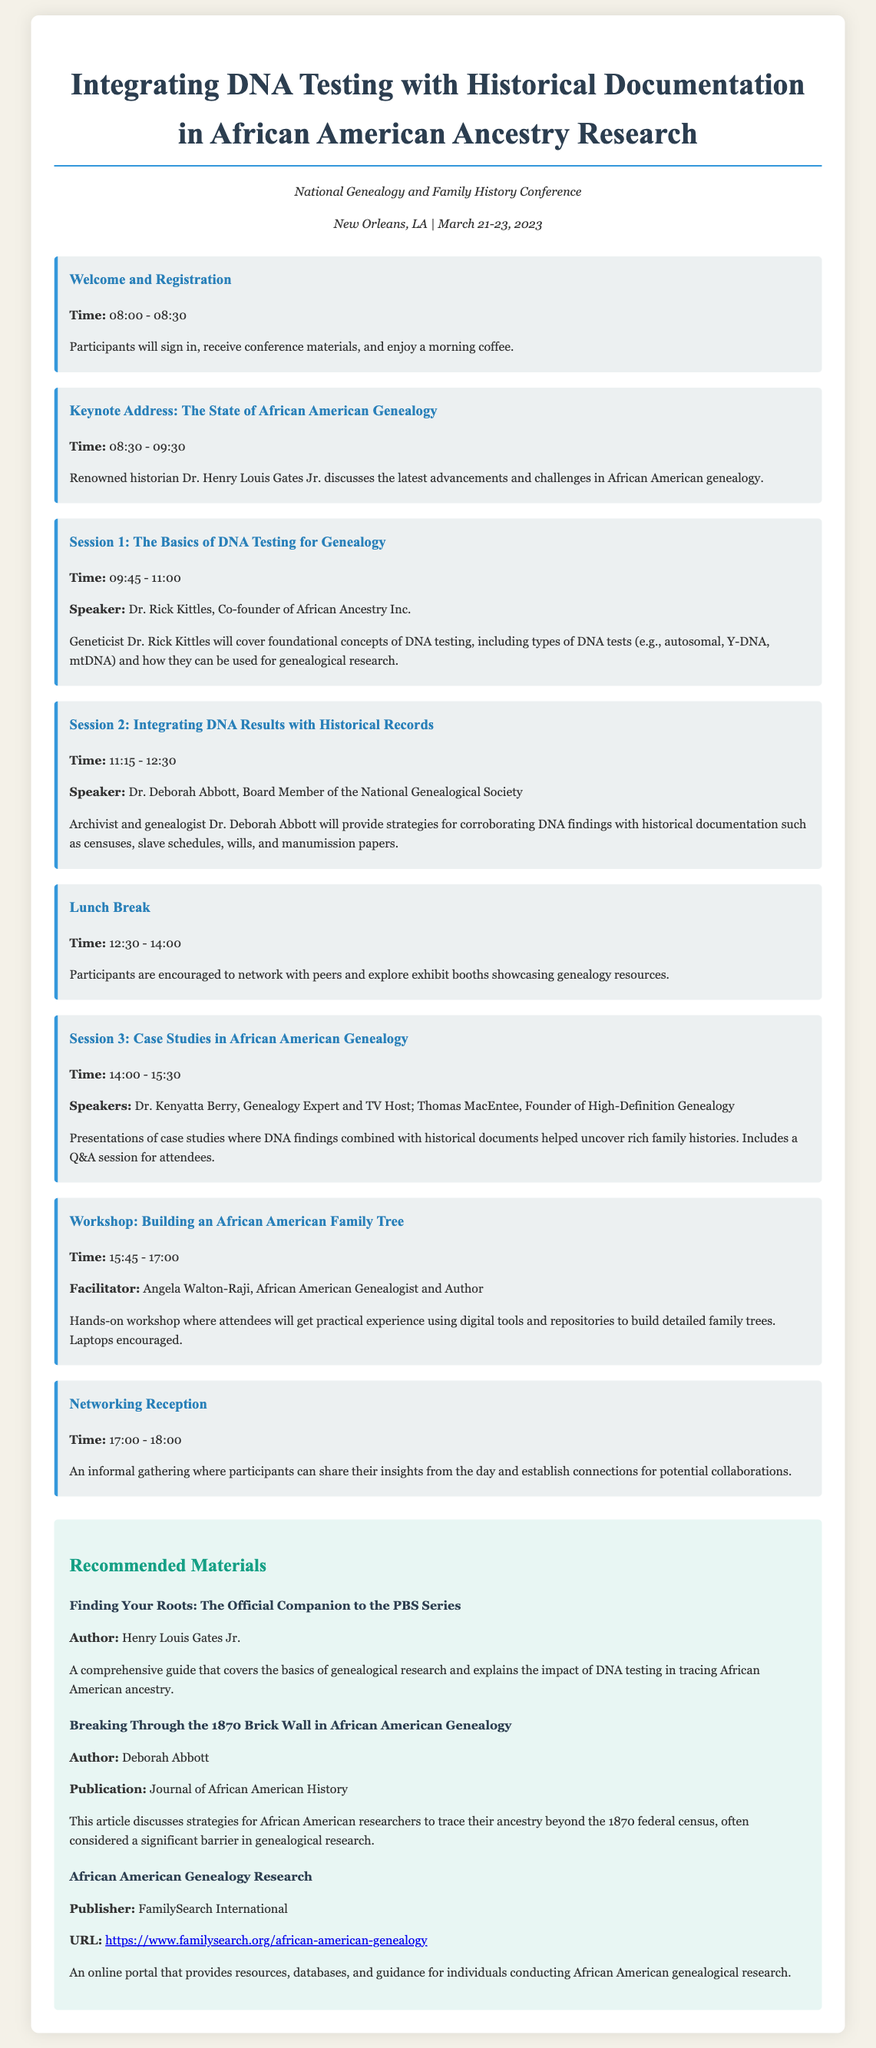What is the title of the workshop? The title of the workshop is stated prominently at the beginning of the document.
Answer: Integrating DNA Testing with Historical Documentation in African American Ancestry Research Who is the keynote speaker? The keynote speaker is mentioned in the schedule section of the document.
Answer: Dr. Henry Louis Gates Jr What time does the networking reception start? The time for the networking reception is provided in the schedule of sessions.
Answer: 17:00 What is the main focus of Session 2? The main focus of Session 2 is described in the session details, highlighting the subject matter covered.
Answer: Integrating DNA Results with Historical Records Who is facilitating the workshop on building an African American family tree? The facilitator for the workshop is listed in the schedule, providing the name of the person leading the session.
Answer: Angela Walton-Raji What is one of the recommended materials? The document contains a list of materials recommended for further reading and research.
Answer: Finding Your Roots: The Official Companion to the PBS Series What publication features an article by Deborah Abbott? The publication where Deborah Abbott's article is featured is specified in the materials section.
Answer: Journal of African American History What are participants encouraged to do during the lunch break? The document specifies activities for participants during the lunch break.
Answer: Network with peers and explore exhibit booths 